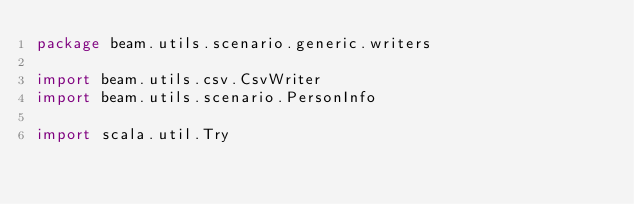Convert code to text. <code><loc_0><loc_0><loc_500><loc_500><_Scala_>package beam.utils.scenario.generic.writers

import beam.utils.csv.CsvWriter
import beam.utils.scenario.PersonInfo

import scala.util.Try
</code> 